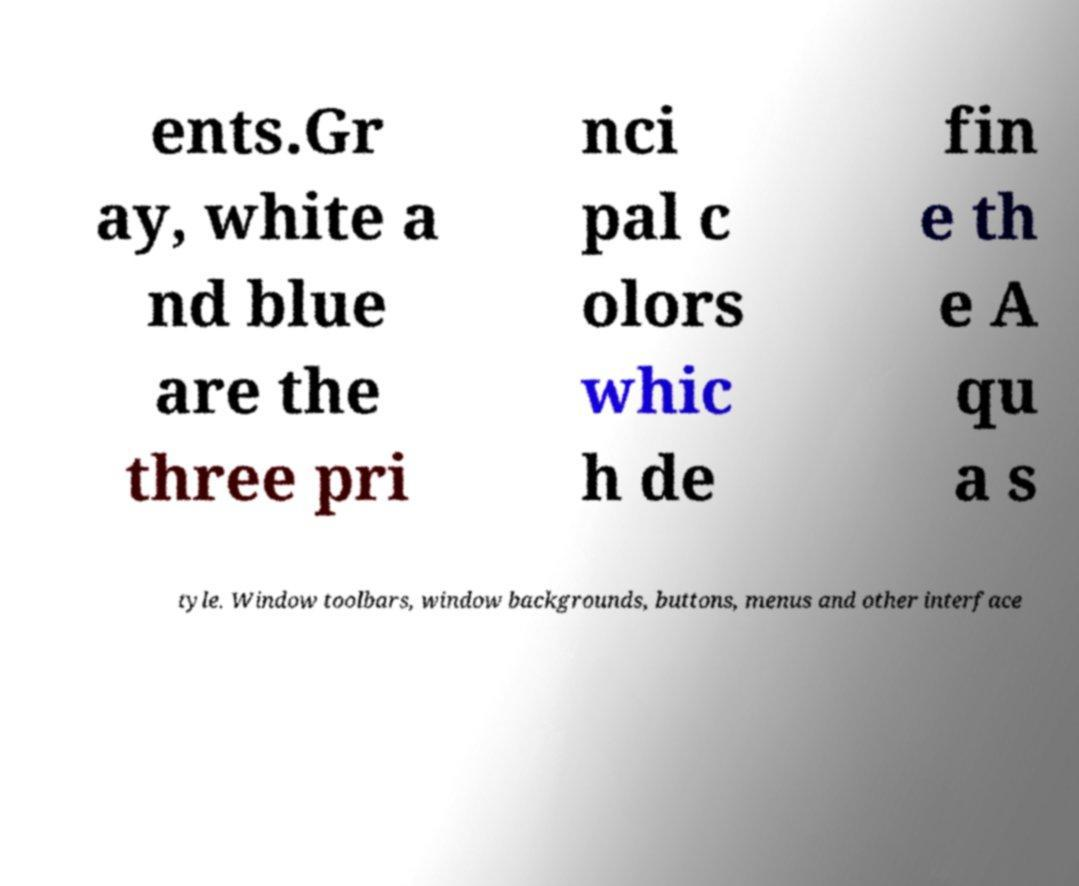Please identify and transcribe the text found in this image. ents.Gr ay, white a nd blue are the three pri nci pal c olors whic h de fin e th e A qu a s tyle. Window toolbars, window backgrounds, buttons, menus and other interface 